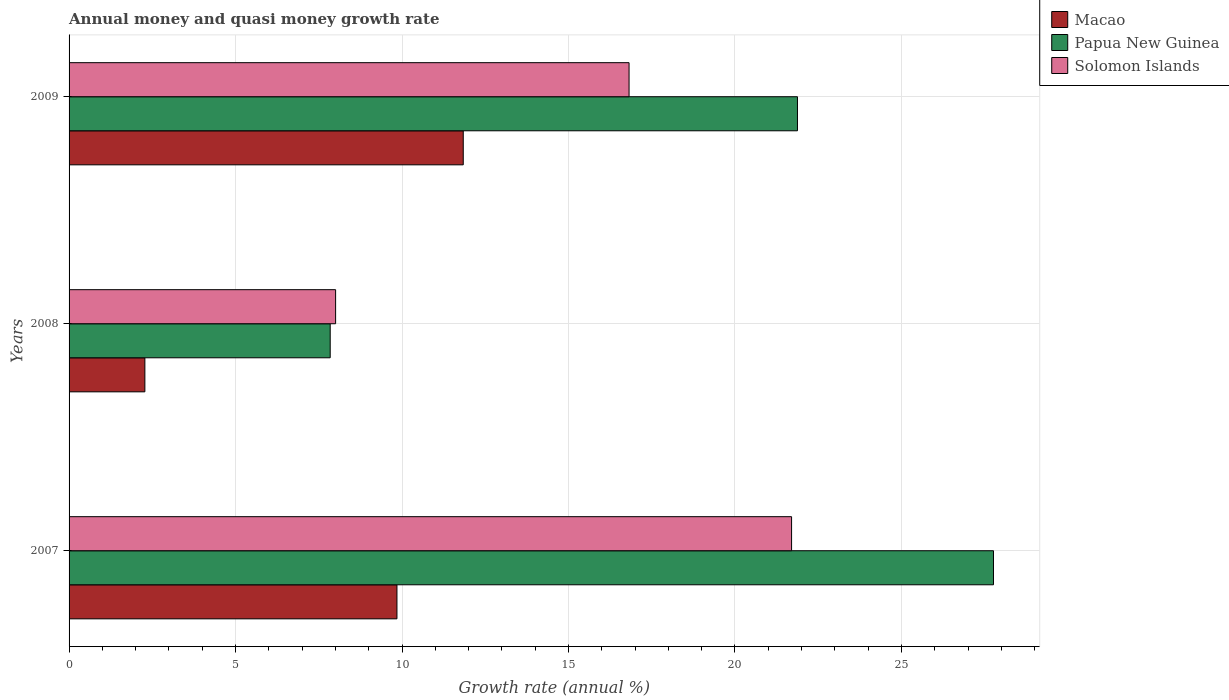Are the number of bars per tick equal to the number of legend labels?
Offer a terse response. Yes. How many bars are there on the 3rd tick from the top?
Offer a very short reply. 3. How many bars are there on the 1st tick from the bottom?
Make the answer very short. 3. What is the label of the 3rd group of bars from the top?
Your answer should be compact. 2007. What is the growth rate in Solomon Islands in 2009?
Your answer should be compact. 16.82. Across all years, what is the maximum growth rate in Solomon Islands?
Make the answer very short. 21.7. Across all years, what is the minimum growth rate in Papua New Guinea?
Offer a very short reply. 7.84. In which year was the growth rate in Papua New Guinea maximum?
Your answer should be very brief. 2007. What is the total growth rate in Papua New Guinea in the graph?
Make the answer very short. 57.49. What is the difference between the growth rate in Macao in 2008 and that in 2009?
Make the answer very short. -9.56. What is the difference between the growth rate in Solomon Islands in 2009 and the growth rate in Papua New Guinea in 2008?
Keep it short and to the point. 8.98. What is the average growth rate in Papua New Guinea per year?
Your answer should be compact. 19.16. In the year 2008, what is the difference between the growth rate in Papua New Guinea and growth rate in Solomon Islands?
Give a very brief answer. -0.16. What is the ratio of the growth rate in Macao in 2008 to that in 2009?
Ensure brevity in your answer.  0.19. What is the difference between the highest and the second highest growth rate in Solomon Islands?
Offer a terse response. 4.88. What is the difference between the highest and the lowest growth rate in Papua New Guinea?
Provide a succinct answer. 19.92. What does the 1st bar from the top in 2007 represents?
Your answer should be compact. Solomon Islands. What does the 1st bar from the bottom in 2007 represents?
Provide a short and direct response. Macao. How many bars are there?
Provide a succinct answer. 9. How many years are there in the graph?
Your answer should be very brief. 3. What is the difference between two consecutive major ticks on the X-axis?
Keep it short and to the point. 5. Does the graph contain any zero values?
Make the answer very short. No. Does the graph contain grids?
Your answer should be very brief. Yes. How many legend labels are there?
Your response must be concise. 3. What is the title of the graph?
Your answer should be very brief. Annual money and quasi money growth rate. What is the label or title of the X-axis?
Keep it short and to the point. Growth rate (annual %). What is the label or title of the Y-axis?
Your answer should be compact. Years. What is the Growth rate (annual %) of Macao in 2007?
Keep it short and to the point. 9.85. What is the Growth rate (annual %) of Papua New Guinea in 2007?
Your answer should be compact. 27.76. What is the Growth rate (annual %) of Solomon Islands in 2007?
Your response must be concise. 21.7. What is the Growth rate (annual %) in Macao in 2008?
Your answer should be compact. 2.28. What is the Growth rate (annual %) of Papua New Guinea in 2008?
Offer a terse response. 7.84. What is the Growth rate (annual %) of Solomon Islands in 2008?
Your response must be concise. 8.01. What is the Growth rate (annual %) of Macao in 2009?
Give a very brief answer. 11.84. What is the Growth rate (annual %) in Papua New Guinea in 2009?
Your answer should be very brief. 21.88. What is the Growth rate (annual %) of Solomon Islands in 2009?
Your answer should be very brief. 16.82. Across all years, what is the maximum Growth rate (annual %) of Macao?
Offer a terse response. 11.84. Across all years, what is the maximum Growth rate (annual %) in Papua New Guinea?
Your answer should be compact. 27.76. Across all years, what is the maximum Growth rate (annual %) in Solomon Islands?
Offer a very short reply. 21.7. Across all years, what is the minimum Growth rate (annual %) of Macao?
Offer a very short reply. 2.28. Across all years, what is the minimum Growth rate (annual %) in Papua New Guinea?
Provide a succinct answer. 7.84. Across all years, what is the minimum Growth rate (annual %) in Solomon Islands?
Make the answer very short. 8.01. What is the total Growth rate (annual %) of Macao in the graph?
Offer a terse response. 23.96. What is the total Growth rate (annual %) of Papua New Guinea in the graph?
Provide a succinct answer. 57.49. What is the total Growth rate (annual %) in Solomon Islands in the graph?
Give a very brief answer. 46.53. What is the difference between the Growth rate (annual %) in Macao in 2007 and that in 2008?
Provide a succinct answer. 7.57. What is the difference between the Growth rate (annual %) in Papua New Guinea in 2007 and that in 2008?
Offer a terse response. 19.92. What is the difference between the Growth rate (annual %) in Solomon Islands in 2007 and that in 2008?
Offer a terse response. 13.7. What is the difference between the Growth rate (annual %) in Macao in 2007 and that in 2009?
Provide a succinct answer. -1.99. What is the difference between the Growth rate (annual %) in Papua New Guinea in 2007 and that in 2009?
Your answer should be compact. 5.89. What is the difference between the Growth rate (annual %) in Solomon Islands in 2007 and that in 2009?
Ensure brevity in your answer.  4.88. What is the difference between the Growth rate (annual %) of Macao in 2008 and that in 2009?
Provide a short and direct response. -9.56. What is the difference between the Growth rate (annual %) of Papua New Guinea in 2008 and that in 2009?
Give a very brief answer. -14.03. What is the difference between the Growth rate (annual %) of Solomon Islands in 2008 and that in 2009?
Give a very brief answer. -8.81. What is the difference between the Growth rate (annual %) in Macao in 2007 and the Growth rate (annual %) in Papua New Guinea in 2008?
Keep it short and to the point. 2. What is the difference between the Growth rate (annual %) in Macao in 2007 and the Growth rate (annual %) in Solomon Islands in 2008?
Your answer should be compact. 1.84. What is the difference between the Growth rate (annual %) of Papua New Guinea in 2007 and the Growth rate (annual %) of Solomon Islands in 2008?
Give a very brief answer. 19.76. What is the difference between the Growth rate (annual %) of Macao in 2007 and the Growth rate (annual %) of Papua New Guinea in 2009?
Offer a terse response. -12.03. What is the difference between the Growth rate (annual %) in Macao in 2007 and the Growth rate (annual %) in Solomon Islands in 2009?
Provide a short and direct response. -6.97. What is the difference between the Growth rate (annual %) of Papua New Guinea in 2007 and the Growth rate (annual %) of Solomon Islands in 2009?
Ensure brevity in your answer.  10.95. What is the difference between the Growth rate (annual %) of Macao in 2008 and the Growth rate (annual %) of Papua New Guinea in 2009?
Offer a very short reply. -19.6. What is the difference between the Growth rate (annual %) of Macao in 2008 and the Growth rate (annual %) of Solomon Islands in 2009?
Your response must be concise. -14.54. What is the difference between the Growth rate (annual %) of Papua New Guinea in 2008 and the Growth rate (annual %) of Solomon Islands in 2009?
Your answer should be very brief. -8.98. What is the average Growth rate (annual %) of Macao per year?
Provide a short and direct response. 7.99. What is the average Growth rate (annual %) of Papua New Guinea per year?
Provide a short and direct response. 19.16. What is the average Growth rate (annual %) in Solomon Islands per year?
Give a very brief answer. 15.51. In the year 2007, what is the difference between the Growth rate (annual %) in Macao and Growth rate (annual %) in Papua New Guinea?
Ensure brevity in your answer.  -17.92. In the year 2007, what is the difference between the Growth rate (annual %) of Macao and Growth rate (annual %) of Solomon Islands?
Offer a very short reply. -11.85. In the year 2007, what is the difference between the Growth rate (annual %) of Papua New Guinea and Growth rate (annual %) of Solomon Islands?
Give a very brief answer. 6.06. In the year 2008, what is the difference between the Growth rate (annual %) in Macao and Growth rate (annual %) in Papua New Guinea?
Ensure brevity in your answer.  -5.57. In the year 2008, what is the difference between the Growth rate (annual %) in Macao and Growth rate (annual %) in Solomon Islands?
Offer a terse response. -5.73. In the year 2008, what is the difference between the Growth rate (annual %) of Papua New Guinea and Growth rate (annual %) of Solomon Islands?
Your answer should be very brief. -0.16. In the year 2009, what is the difference between the Growth rate (annual %) of Macao and Growth rate (annual %) of Papua New Guinea?
Offer a terse response. -10.04. In the year 2009, what is the difference between the Growth rate (annual %) in Macao and Growth rate (annual %) in Solomon Islands?
Make the answer very short. -4.98. In the year 2009, what is the difference between the Growth rate (annual %) of Papua New Guinea and Growth rate (annual %) of Solomon Islands?
Your response must be concise. 5.06. What is the ratio of the Growth rate (annual %) in Macao in 2007 to that in 2008?
Offer a terse response. 4.33. What is the ratio of the Growth rate (annual %) of Papua New Guinea in 2007 to that in 2008?
Provide a short and direct response. 3.54. What is the ratio of the Growth rate (annual %) in Solomon Islands in 2007 to that in 2008?
Your answer should be very brief. 2.71. What is the ratio of the Growth rate (annual %) in Macao in 2007 to that in 2009?
Offer a terse response. 0.83. What is the ratio of the Growth rate (annual %) in Papua New Guinea in 2007 to that in 2009?
Offer a very short reply. 1.27. What is the ratio of the Growth rate (annual %) of Solomon Islands in 2007 to that in 2009?
Ensure brevity in your answer.  1.29. What is the ratio of the Growth rate (annual %) in Macao in 2008 to that in 2009?
Provide a short and direct response. 0.19. What is the ratio of the Growth rate (annual %) in Papua New Guinea in 2008 to that in 2009?
Ensure brevity in your answer.  0.36. What is the ratio of the Growth rate (annual %) of Solomon Islands in 2008 to that in 2009?
Your answer should be very brief. 0.48. What is the difference between the highest and the second highest Growth rate (annual %) in Macao?
Ensure brevity in your answer.  1.99. What is the difference between the highest and the second highest Growth rate (annual %) in Papua New Guinea?
Provide a succinct answer. 5.89. What is the difference between the highest and the second highest Growth rate (annual %) in Solomon Islands?
Provide a short and direct response. 4.88. What is the difference between the highest and the lowest Growth rate (annual %) of Macao?
Provide a short and direct response. 9.56. What is the difference between the highest and the lowest Growth rate (annual %) in Papua New Guinea?
Your answer should be compact. 19.92. What is the difference between the highest and the lowest Growth rate (annual %) of Solomon Islands?
Your response must be concise. 13.7. 